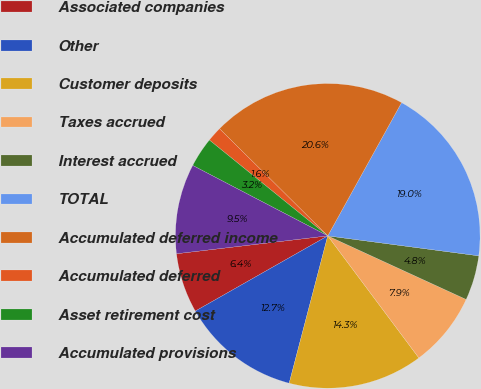<chart> <loc_0><loc_0><loc_500><loc_500><pie_chart><fcel>Associated companies<fcel>Other<fcel>Customer deposits<fcel>Taxes accrued<fcel>Interest accrued<fcel>TOTAL<fcel>Accumulated deferred income<fcel>Accumulated deferred<fcel>Asset retirement cost<fcel>Accumulated provisions<nl><fcel>6.35%<fcel>12.7%<fcel>14.28%<fcel>7.94%<fcel>4.76%<fcel>19.04%<fcel>20.63%<fcel>1.59%<fcel>3.18%<fcel>9.52%<nl></chart> 